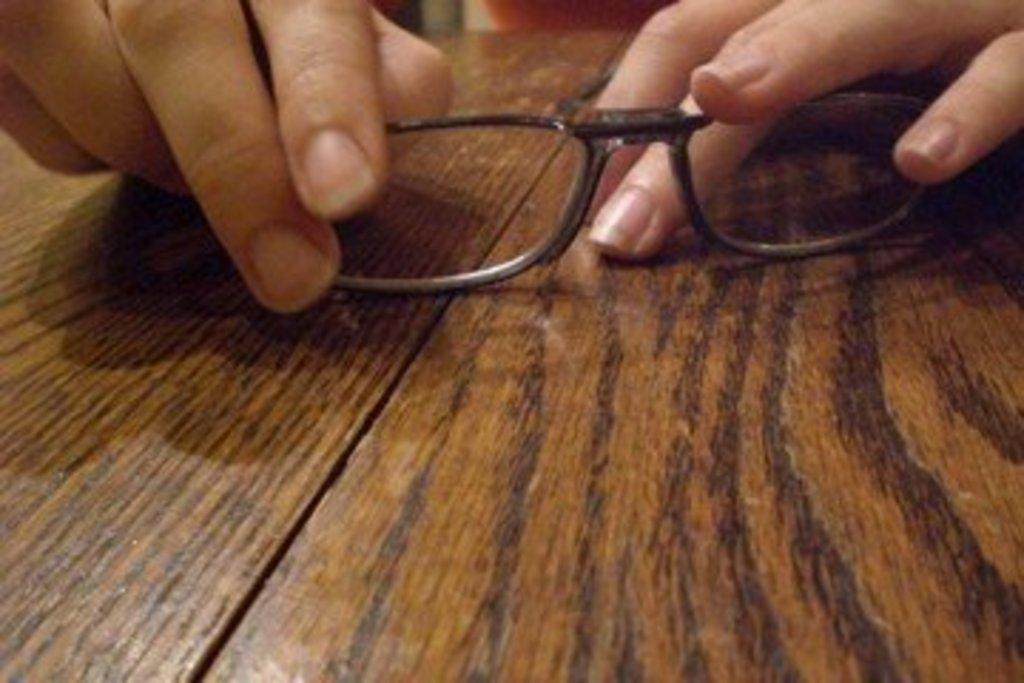Describe this image in one or two sentences. In the picture we can see a wooden table on it we can see a person hand holding an optical. 